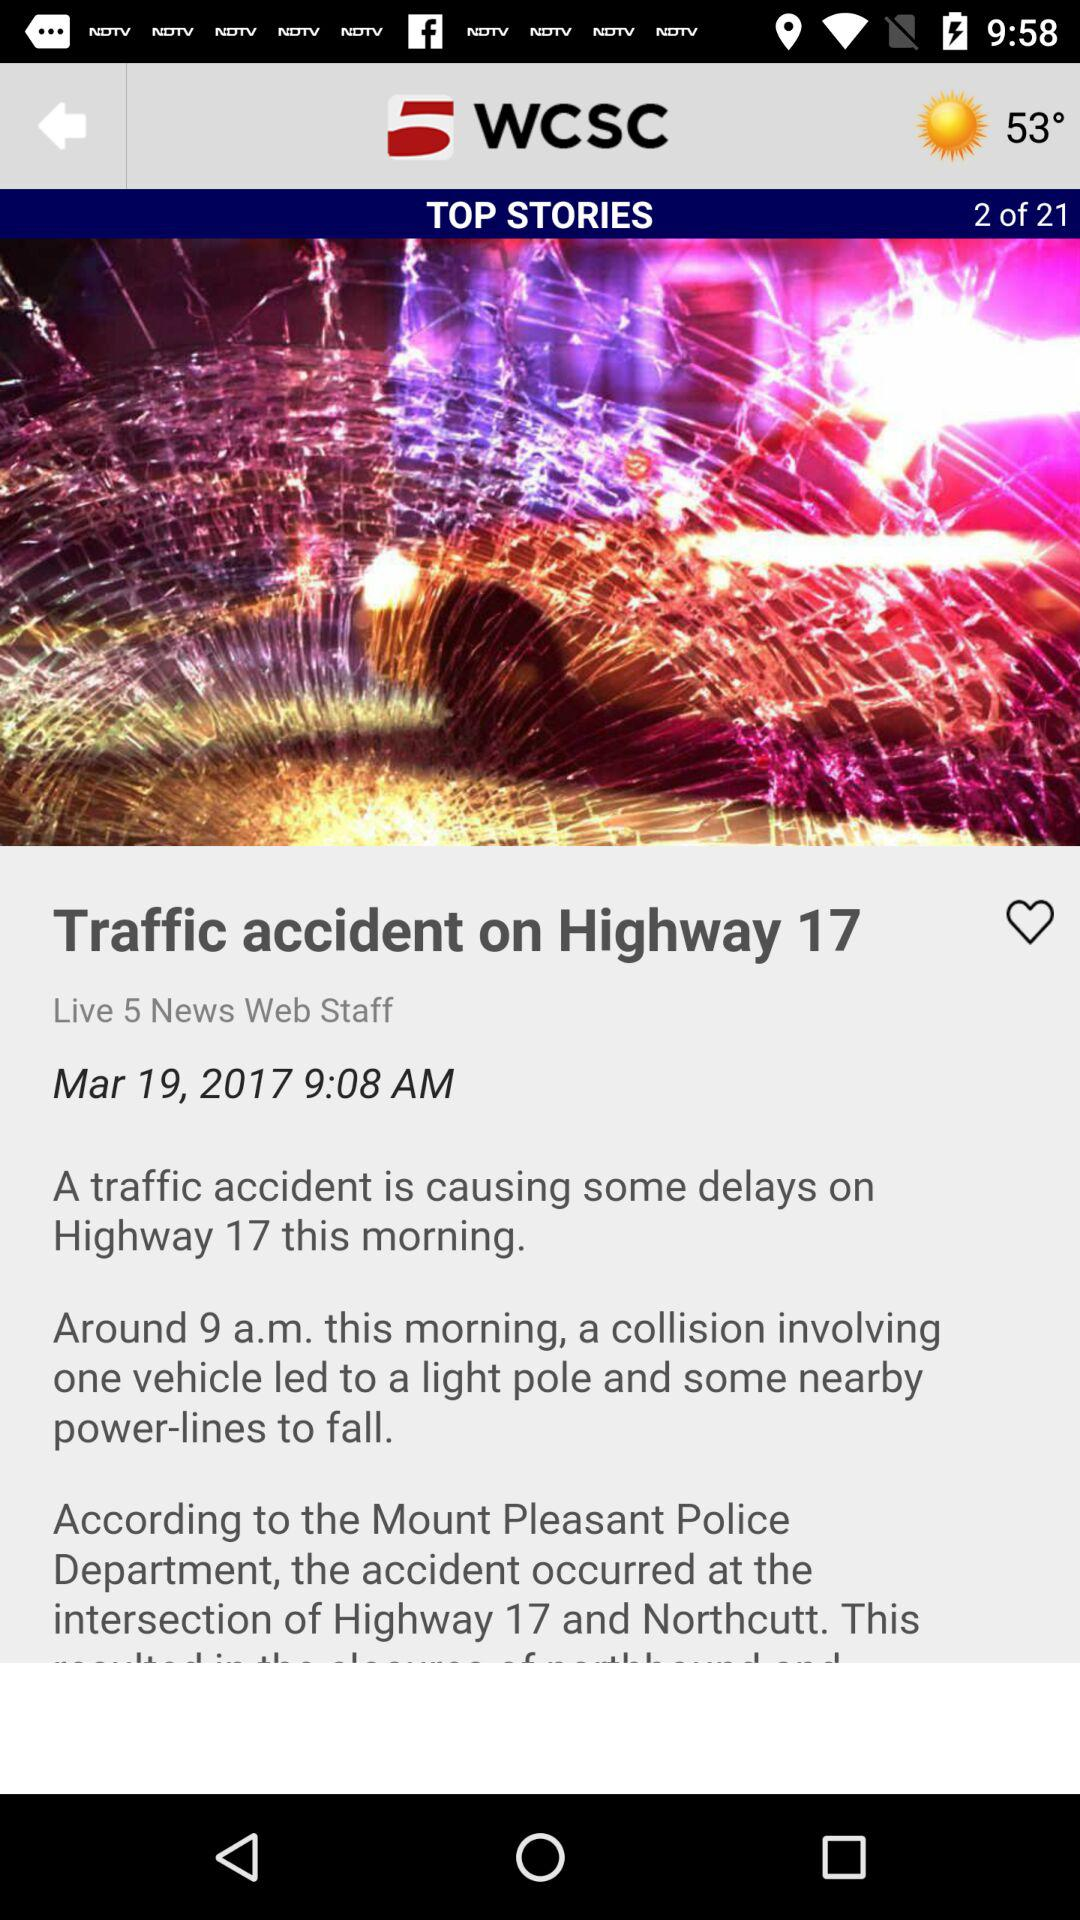What is the temperature? The temperature is 53°. 